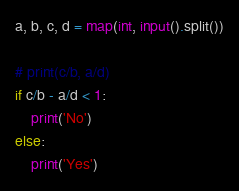<code> <loc_0><loc_0><loc_500><loc_500><_Python_>a, b, c, d = map(int, input().split())

# print(c/b, a/d)
if c/b - a/d < 1:
    print('No')
else:
    print('Yes')</code> 